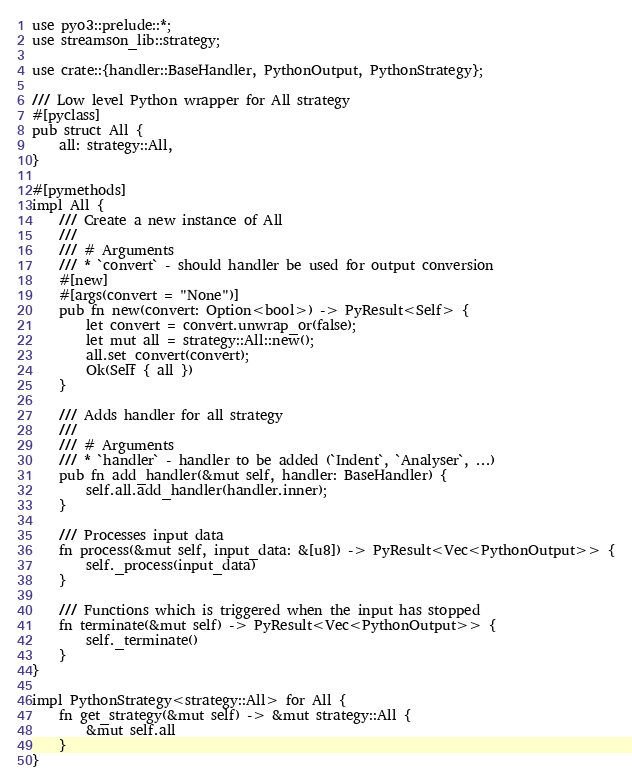<code> <loc_0><loc_0><loc_500><loc_500><_Rust_>use pyo3::prelude::*;
use streamson_lib::strategy;

use crate::{handler::BaseHandler, PythonOutput, PythonStrategy};

/// Low level Python wrapper for All strategy
#[pyclass]
pub struct All {
    all: strategy::All,
}

#[pymethods]
impl All {
    /// Create a new instance of All
    ///
    /// # Arguments
    /// * `convert` - should handler be used for output conversion
    #[new]
    #[args(convert = "None")]
    pub fn new(convert: Option<bool>) -> PyResult<Self> {
        let convert = convert.unwrap_or(false);
        let mut all = strategy::All::new();
        all.set_convert(convert);
        Ok(Self { all })
    }

    /// Adds handler for all strategy
    ///
    /// # Arguments
    /// * `handler` - handler to be added (`Indent`, `Analyser`, ...)
    pub fn add_handler(&mut self, handler: BaseHandler) {
        self.all.add_handler(handler.inner);
    }

    /// Processes input data
    fn process(&mut self, input_data: &[u8]) -> PyResult<Vec<PythonOutput>> {
        self._process(input_data)
    }

    /// Functions which is triggered when the input has stopped
    fn terminate(&mut self) -> PyResult<Vec<PythonOutput>> {
        self._terminate()
    }
}

impl PythonStrategy<strategy::All> for All {
    fn get_strategy(&mut self) -> &mut strategy::All {
        &mut self.all
    }
}
</code> 